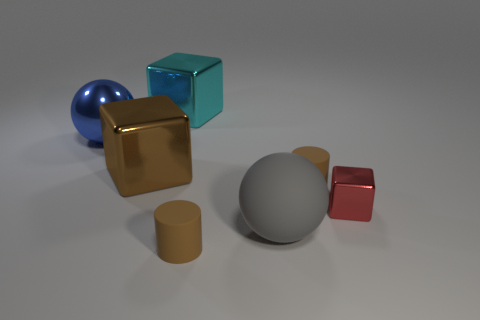Does the large blue thing have the same material as the big block in front of the big blue metallic object?
Make the answer very short. Yes. What number of other things are the same shape as the large blue shiny object?
Keep it short and to the point. 1. What number of objects are either large shiny objects that are in front of the big blue shiny object or objects behind the brown cube?
Give a very brief answer. 3. How many other things are the same color as the matte ball?
Your answer should be very brief. 0. Is the number of large brown shiny things to the left of the big brown object less than the number of red shiny things that are in front of the large matte object?
Give a very brief answer. No. How many cylinders are there?
Provide a short and direct response. 2. Is there any other thing that is made of the same material as the red cube?
Ensure brevity in your answer.  Yes. What is the material of the other thing that is the same shape as the big gray object?
Offer a very short reply. Metal. Is the number of brown shiny things that are left of the large shiny ball less than the number of yellow metal things?
Offer a very short reply. No. There is a brown matte object that is on the right side of the big gray matte ball; is its shape the same as the gray object?
Your answer should be very brief. No. 